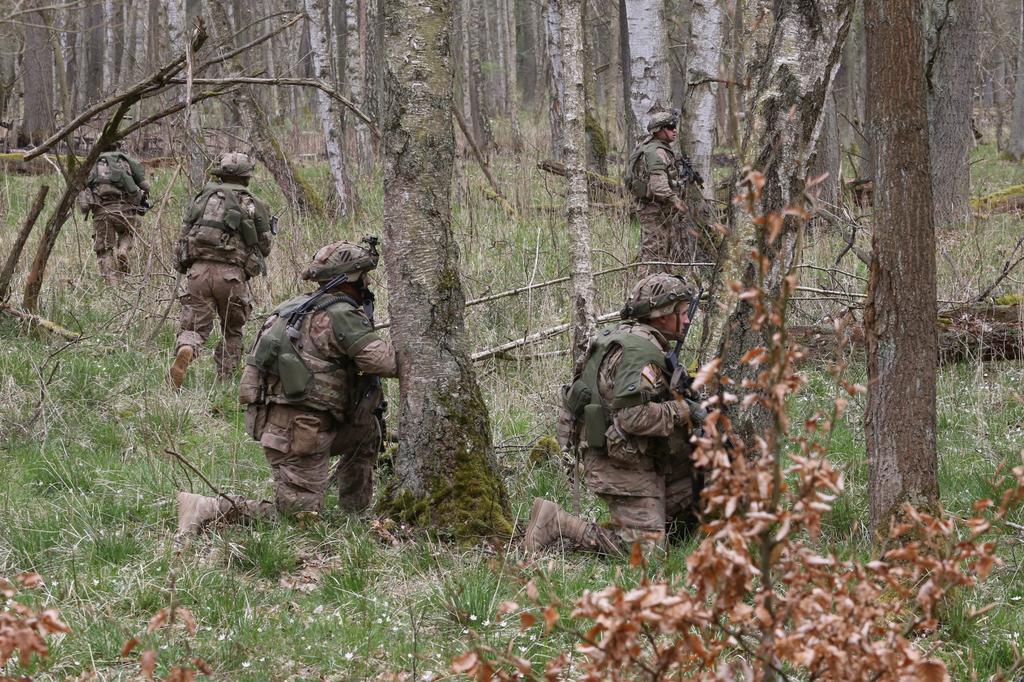Could you give a brief overview of what you see in this image? In this image we can see people wearing military uniform and helmets. There are trees. At the bottom of the image there is grass. 